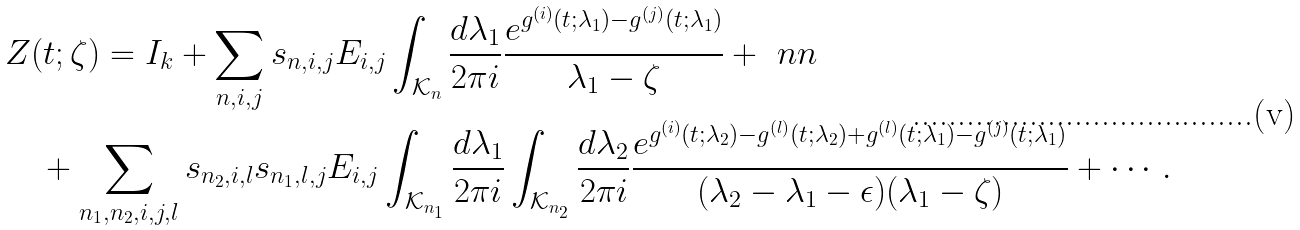<formula> <loc_0><loc_0><loc_500><loc_500>& Z ( t ; \zeta ) = I _ { k } + \sum _ { n , i , j } s _ { n , i , j } E _ { i , j } \int _ { \mathcal { K } _ { n } } \frac { d \lambda _ { 1 } } { 2 \pi i } \frac { e ^ { g ^ { ( i ) } ( t ; \lambda _ { 1 } ) - g ^ { ( j ) } ( t ; \lambda _ { 1 } ) } } { \lambda _ { 1 } - \zeta } + \ n n \\ & \quad + \sum _ { n _ { 1 } , n _ { 2 } , i , j , l } s _ { n _ { 2 } , i , l } s _ { n _ { 1 } , l , j } E _ { i , j } \int _ { \mathcal { K } _ { n _ { 1 } } } \frac { d \lambda _ { 1 } } { 2 \pi i } \int _ { \mathcal { K } _ { n _ { 2 } } } \frac { d \lambda _ { 2 } } { 2 \pi i } \frac { e ^ { g ^ { ( i ) } ( t ; \lambda _ { 2 } ) - g ^ { ( l ) } ( t ; \lambda _ { 2 } ) + g ^ { ( l ) } ( t ; \lambda _ { 1 } ) - g ^ { ( j ) } ( t ; \lambda _ { 1 } ) } } { ( \lambda _ { 2 } - \lambda _ { 1 } - \epsilon ) ( \lambda _ { 1 } - \zeta ) } + \cdots .</formula> 